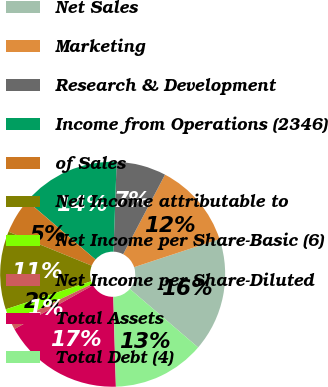Convert chart to OTSL. <chart><loc_0><loc_0><loc_500><loc_500><pie_chart><fcel>Net Sales<fcel>Marketing<fcel>Research & Development<fcel>Income from Operations (2346)<fcel>of Sales<fcel>Net Income attributable to<fcel>Net Income per Share-Basic (6)<fcel>Net Income per Share-Diluted<fcel>Total Assets<fcel>Total Debt (4)<nl><fcel>16.33%<fcel>12.24%<fcel>7.14%<fcel>14.29%<fcel>5.1%<fcel>11.22%<fcel>2.04%<fcel>1.02%<fcel>17.35%<fcel>13.27%<nl></chart> 